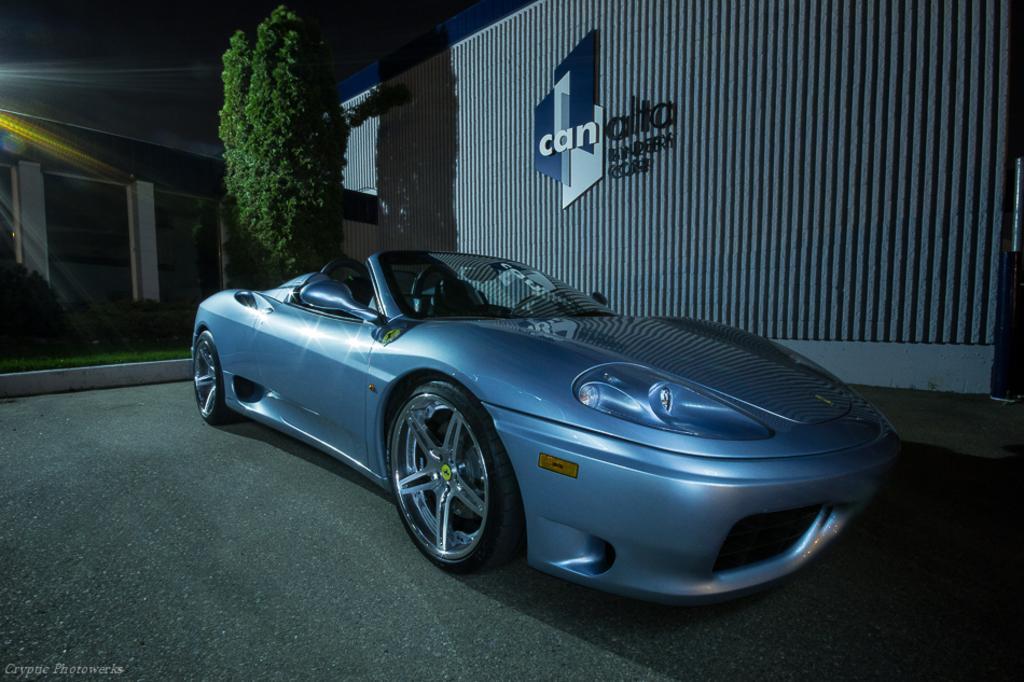Describe this image in one or two sentences. In the image I can see there is a car on the road. And at the back there is a building, Grass and tree. Beside the tree there is a wall with text. And at the top there is a sky. 